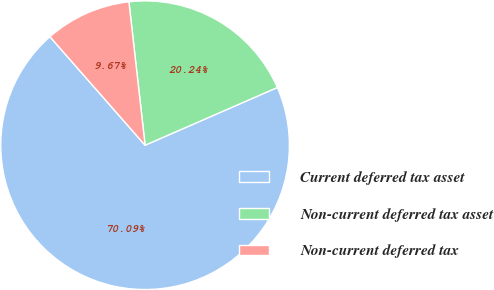Convert chart to OTSL. <chart><loc_0><loc_0><loc_500><loc_500><pie_chart><fcel>Current deferred tax asset<fcel>Non-current deferred tax asset<fcel>Non-current deferred tax<nl><fcel>70.09%<fcel>20.24%<fcel>9.67%<nl></chart> 